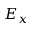Convert formula to latex. <formula><loc_0><loc_0><loc_500><loc_500>E _ { x }</formula> 